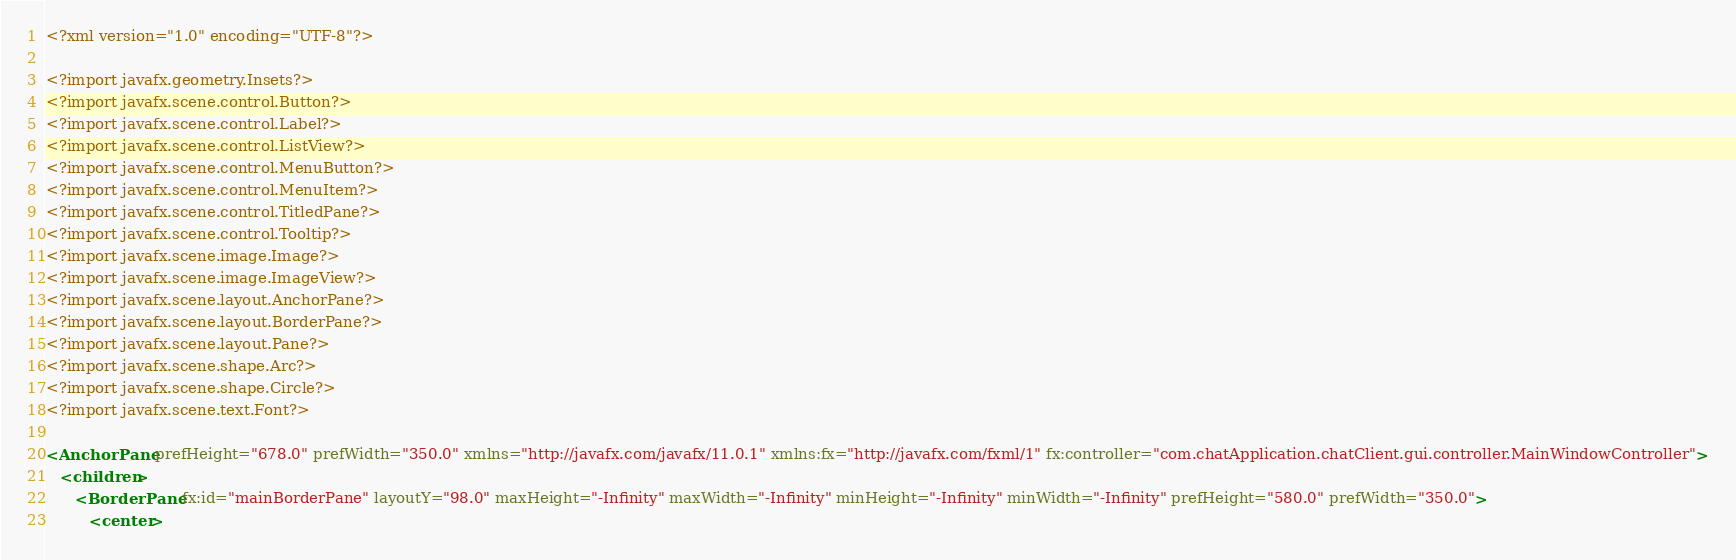Convert code to text. <code><loc_0><loc_0><loc_500><loc_500><_XML_><?xml version="1.0" encoding="UTF-8"?>

<?import javafx.geometry.Insets?>
<?import javafx.scene.control.Button?>
<?import javafx.scene.control.Label?>
<?import javafx.scene.control.ListView?>
<?import javafx.scene.control.MenuButton?>
<?import javafx.scene.control.MenuItem?>
<?import javafx.scene.control.TitledPane?>
<?import javafx.scene.control.Tooltip?>
<?import javafx.scene.image.Image?>
<?import javafx.scene.image.ImageView?>
<?import javafx.scene.layout.AnchorPane?>
<?import javafx.scene.layout.BorderPane?>
<?import javafx.scene.layout.Pane?>
<?import javafx.scene.shape.Arc?>
<?import javafx.scene.shape.Circle?>
<?import javafx.scene.text.Font?>

<AnchorPane prefHeight="678.0" prefWidth="350.0" xmlns="http://javafx.com/javafx/11.0.1" xmlns:fx="http://javafx.com/fxml/1" fx:controller="com.chatApplication.chatClient.gui.controller.MainWindowController">
   <children>
      <BorderPane fx:id="mainBorderPane" layoutY="98.0" maxHeight="-Infinity" maxWidth="-Infinity" minHeight="-Infinity" minWidth="-Infinity" prefHeight="580.0" prefWidth="350.0">
         <center></code> 